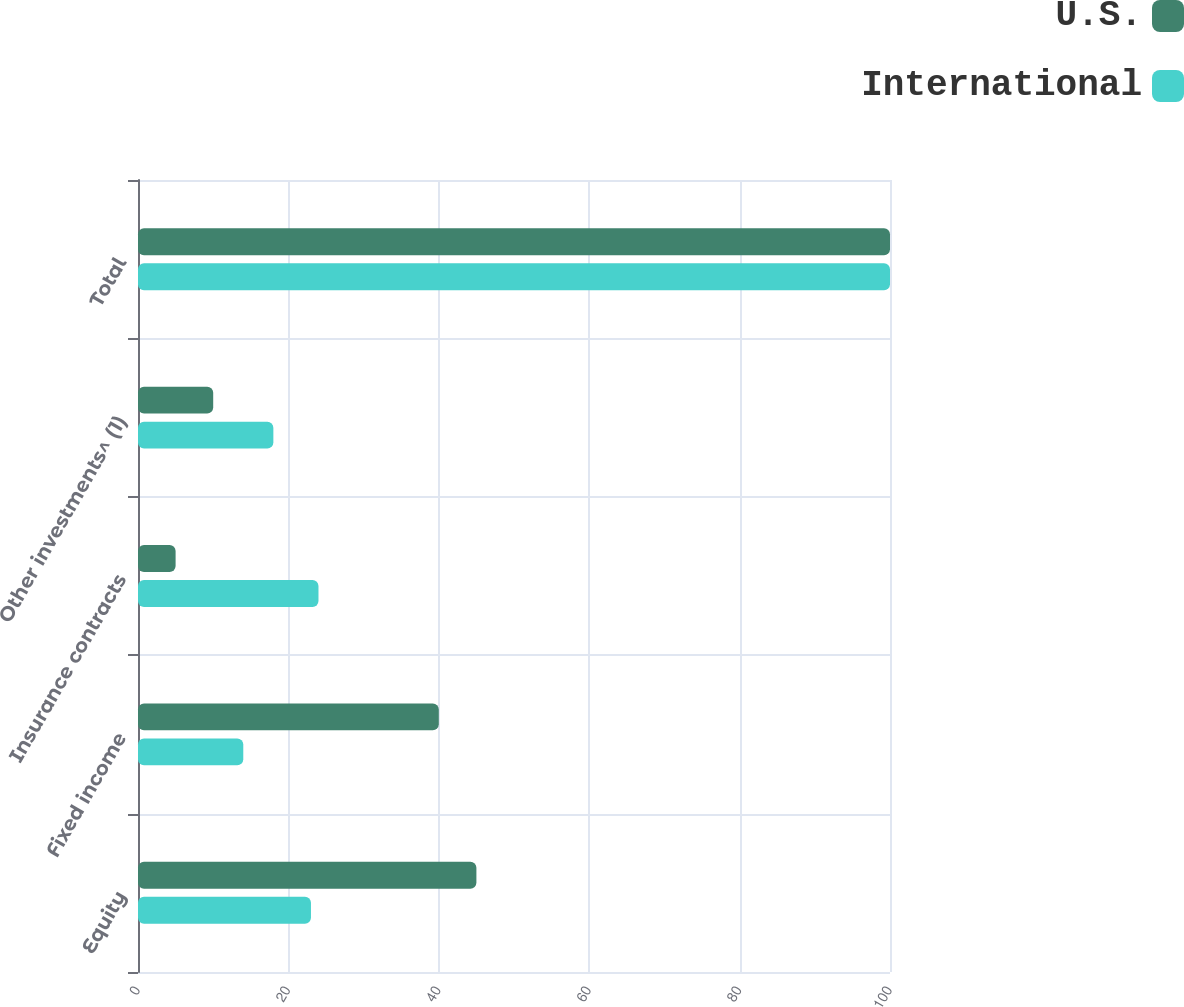Convert chart to OTSL. <chart><loc_0><loc_0><loc_500><loc_500><stacked_bar_chart><ecel><fcel>Equity<fcel>Fixed income<fcel>Insurance contracts<fcel>Other investments^ (1)<fcel>Total<nl><fcel>U.S.<fcel>45<fcel>40<fcel>5<fcel>10<fcel>100<nl><fcel>International<fcel>23<fcel>14<fcel>24<fcel>18<fcel>100<nl></chart> 